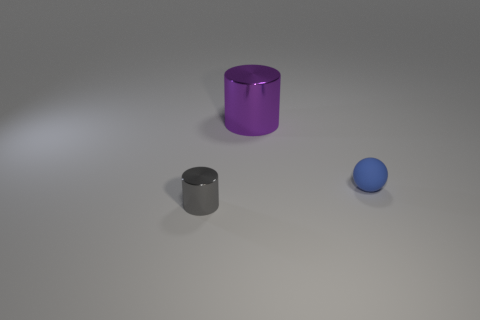There is a purple cylinder that is the same material as the gray cylinder; what is its size?
Your response must be concise. Large. The small thing that is behind the gray cylinder has what shape?
Offer a terse response. Sphere. The other thing that is the same shape as the gray thing is what size?
Ensure brevity in your answer.  Large. What number of small balls are behind the cylinder in front of the metallic cylinder behind the blue ball?
Make the answer very short. 1. Are there the same number of purple cylinders in front of the small blue object and blue matte spheres?
Your answer should be compact. No. What number of blocks are either tiny blue matte things or large things?
Offer a very short reply. 0. Is the number of tiny rubber balls in front of the tiny rubber object the same as the number of tiny objects on the left side of the big object?
Ensure brevity in your answer.  No. What color is the large shiny cylinder?
Make the answer very short. Purple. How many things are cylinders that are in front of the small blue sphere or small gray metal things?
Offer a very short reply. 1. Do the metal cylinder that is behind the small gray object and the shiny cylinder that is in front of the blue rubber thing have the same size?
Keep it short and to the point. No. 